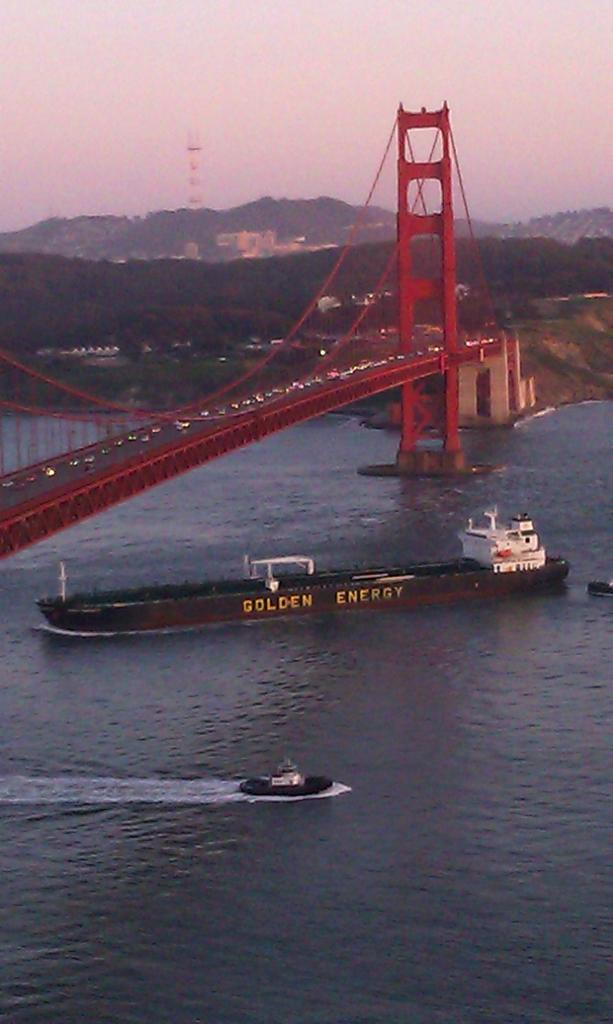What color is the ship in the image? The ship in the image is brown-colored. Where is the ship located? The ship is on the water. What other watercraft is visible in the image? There is a boat beside the ship. What can be seen above the ship in the image? There is a red-colored bridge above the ship. What type of natural scenery is visible in the background of the image? Trees are present in the background of the image. What type of shoe can be seen hanging from the bridge in the image? There is no shoe hanging from the bridge in the image; it only features a red-colored bridge above the ship. 